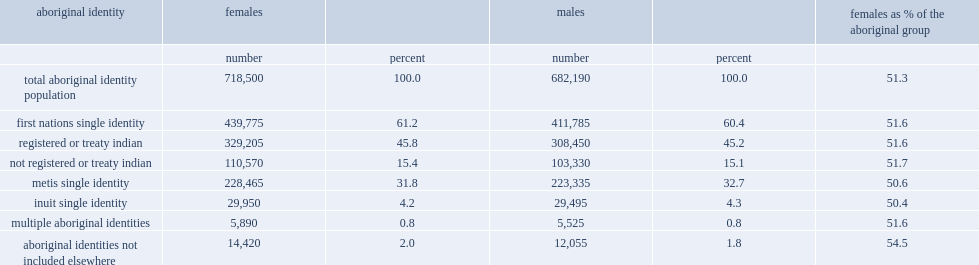How many aboriginal women and girls in canada? 718500.0. Of the women and girls who identified themselves as an aboriginal person, how many percent of people reported being first nations? 61.2. Of the women and girls who identified themselves as an aboriginal person, how many percent of people reported being first nations with registered indian status? 45.8. Of the women and girls who identified themselves as an aboriginal person, how many percent of people reported being first nations? 15.4. Of the women and girls who identified themselves as an aboriginal person, how many percentages of people reported being metis? 31.8. Of the women and girls who identified themselves as an aboriginal person, how many percentages of people reported being inuit identity? 4.2. How many percentages of females reported multiple aboriginal identities? 0.8. How many percentages of females did not identify with an aboriginal group but reported having registered indian status and/or being a member of an indian band? 2.0. As with the total population in canada, how many percentages did women and girls make up of aboriginal people in canada? 51.3. 